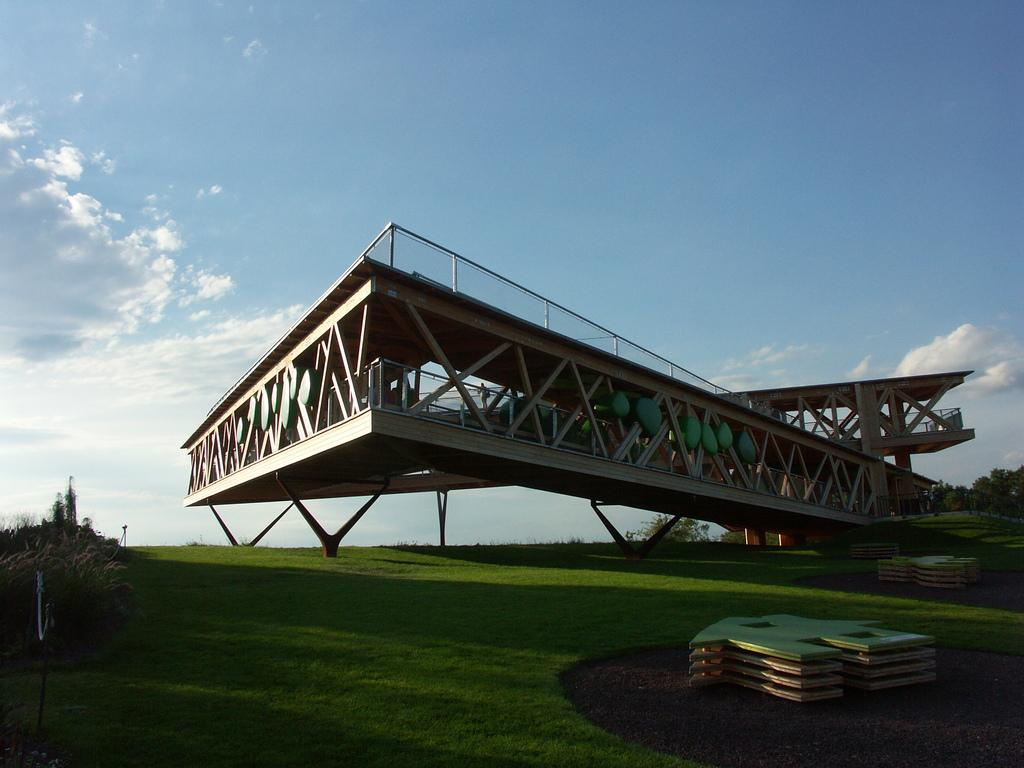What structure can be seen in the image? There is a bridge in the image. What type of vegetation is present in the image? There are trees in the image. What covers the ground in the image? There is grass on the ground in the image. What is visible in the background of the image? The sky is visible in the image. What is the condition of the sky in the image? The sky appears to be cloudy in the image. What type of lipstick is being advertised on the bridge in the image? There is no lipstick or advertisement present on the bridge in the image. How many trains can be seen passing over the bridge in the image? There are no trains visible in the image; it only features a bridge, trees, grass, and a cloudy sky. 